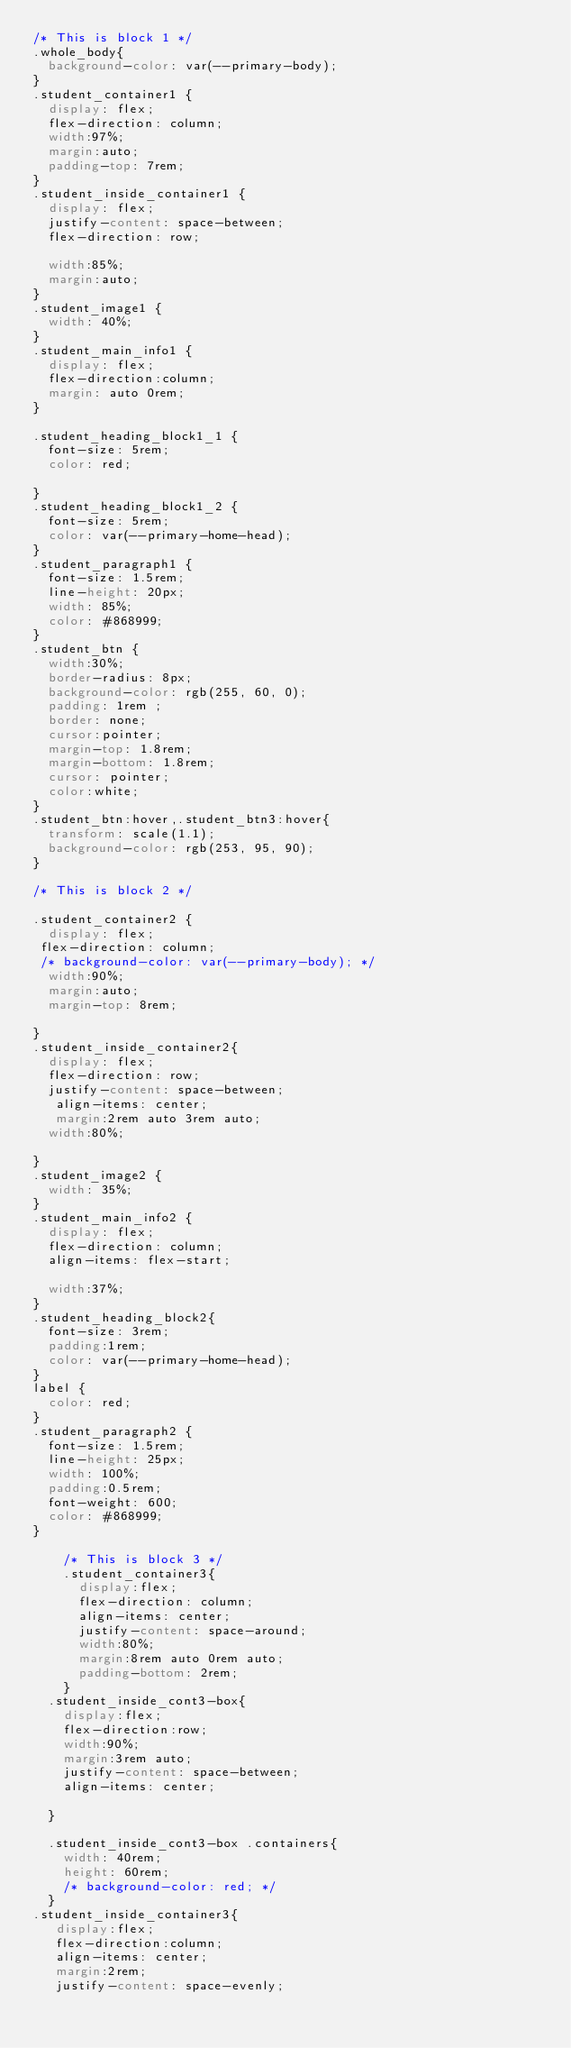<code> <loc_0><loc_0><loc_500><loc_500><_CSS_>/* This is block 1 */
.whole_body{
  background-color: var(--primary-body);
}
.student_container1 {
  display: flex;
  flex-direction: column;
  width:97%; 
  margin:auto;
  padding-top: 7rem;
}
.student_inside_container1 {
  display: flex;
  justify-content: space-between;
  flex-direction: row;

  width:85%;
  margin:auto;
}
.student_image1 {
  width: 40%;
}
.student_main_info1 {
  display: flex;
  flex-direction:column;
  margin: auto 0rem;
}

.student_heading_block1_1 {
  font-size: 5rem;
  color: red;

}
.student_heading_block1_2 {
  font-size: 5rem;
  color: var(--primary-home-head);
}
.student_paragraph1 {
  font-size: 1.5rem;
  line-height: 20px;
  width: 85%;
  color: #868999;
}
.student_btn {
  width:30%;
  border-radius: 8px;
  background-color: rgb(255, 60, 0);
  padding: 1rem ;
  border: none;
  cursor:pointer;
  margin-top: 1.8rem;
  margin-bottom: 1.8rem;
  cursor: pointer;
  color:white;
}
.student_btn:hover,.student_btn3:hover{
  transform: scale(1.1);
  background-color: rgb(253, 95, 90);
}

/* This is block 2 */

.student_container2 {
  display: flex;
 flex-direction: column;
 /* background-color: var(--primary-body); */
  width:90%;
  margin:auto;
  margin-top: 8rem;
  
}
.student_inside_container2{
  display: flex;
  flex-direction: row;
  justify-content: space-between;
   align-items: center;
   margin:2rem auto 3rem auto;
  width:80%;
  
}
.student_image2 {
  width: 35%;
}
.student_main_info2 {
  display: flex;
  flex-direction: column;
  align-items: flex-start;
 
  width:37%;
}
.student_heading_block2{
  font-size: 3rem;
  padding:1rem;
  color: var(--primary-home-head);
}
label {
  color: red;
}
.student_paragraph2 {
  font-size: 1.5rem;
  line-height: 25px;
  width: 100%;
  padding:0.5rem;
  font-weight: 600;
  color: #868999;
}

    /* This is block 3 */
    .student_container3{
      display:flex;
      flex-direction: column;
      align-items: center;
      justify-content: space-around;
      width:80%;
      margin:8rem auto 0rem auto;
      padding-bottom: 2rem;
    }
  .student_inside_cont3-box{
    display:flex;
    flex-direction:row;
    width:90%;
    margin:3rem auto;
    justify-content: space-between;
    align-items: center;

  }

  .student_inside_cont3-box .containers{
    width: 40rem;
    height: 60rem;
    /* background-color: red; */
  }
.student_inside_container3{
   display:flex;
   flex-direction:column;
   align-items: center;
   margin:2rem;
   justify-content: space-evenly;</code> 